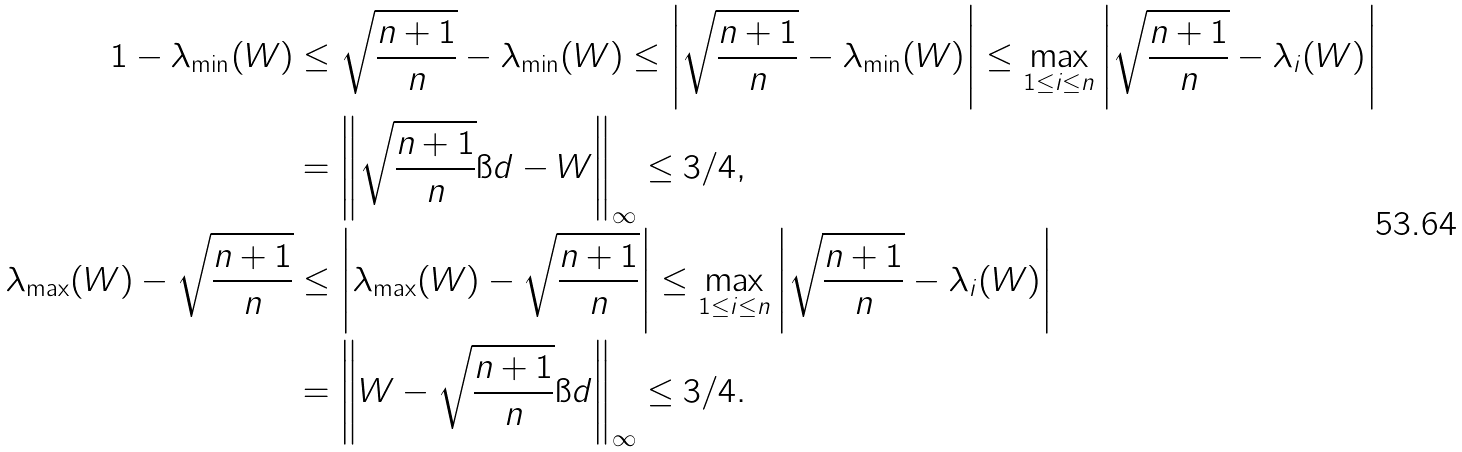Convert formula to latex. <formula><loc_0><loc_0><loc_500><loc_500>1 - \lambda _ { \min } ( W ) & \leq \sqrt { \frac { n + 1 } { n } } - \lambda _ { \min } ( W ) \leq \left | \sqrt { \frac { n + 1 } { n } } - \lambda _ { \min } ( W ) \right | \leq \max _ { 1 \leq i \leq n } \left | \sqrt { \frac { n + 1 } { n } } - \lambda _ { i } ( W ) \right | \\ & = \left \| \sqrt { \frac { n + 1 } { n } } \i d - W \right \| _ { \infty } \leq 3 / 4 , \\ \lambda _ { \max } ( W ) - \sqrt { \frac { n + 1 } { n } } & \leq \left | \lambda _ { \max } ( W ) - \sqrt { \frac { n + 1 } { n } } \right | \leq \max _ { 1 \leq i \leq n } \left | \sqrt { \frac { n + 1 } { n } } - \lambda _ { i } ( W ) \right | \\ & = \left \| W - \sqrt { \frac { n + 1 } { n } } \i d \right \| _ { \infty } \leq 3 / 4 .</formula> 